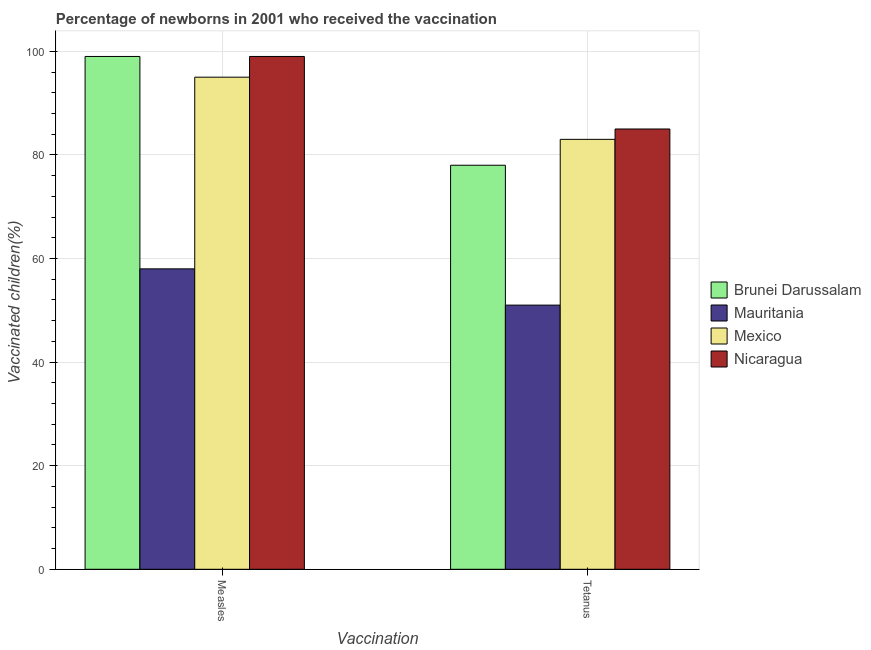How many groups of bars are there?
Your response must be concise. 2. Are the number of bars on each tick of the X-axis equal?
Provide a short and direct response. Yes. What is the label of the 1st group of bars from the left?
Offer a terse response. Measles. What is the percentage of newborns who received vaccination for measles in Nicaragua?
Offer a very short reply. 99. Across all countries, what is the maximum percentage of newborns who received vaccination for measles?
Provide a succinct answer. 99. Across all countries, what is the minimum percentage of newborns who received vaccination for measles?
Offer a very short reply. 58. In which country was the percentage of newborns who received vaccination for tetanus maximum?
Offer a terse response. Nicaragua. In which country was the percentage of newborns who received vaccination for measles minimum?
Your answer should be compact. Mauritania. What is the total percentage of newborns who received vaccination for tetanus in the graph?
Make the answer very short. 297. What is the difference between the percentage of newborns who received vaccination for measles in Mexico and that in Brunei Darussalam?
Provide a succinct answer. -4. What is the difference between the percentage of newborns who received vaccination for measles in Nicaragua and the percentage of newborns who received vaccination for tetanus in Brunei Darussalam?
Ensure brevity in your answer.  21. What is the average percentage of newborns who received vaccination for tetanus per country?
Offer a terse response. 74.25. What is the difference between the percentage of newborns who received vaccination for measles and percentage of newborns who received vaccination for tetanus in Mauritania?
Make the answer very short. 7. Is the percentage of newborns who received vaccination for tetanus in Mauritania less than that in Nicaragua?
Make the answer very short. Yes. In how many countries, is the percentage of newborns who received vaccination for tetanus greater than the average percentage of newborns who received vaccination for tetanus taken over all countries?
Make the answer very short. 3. What does the 3rd bar from the left in Tetanus represents?
Your response must be concise. Mexico. What does the 3rd bar from the right in Measles represents?
Offer a very short reply. Mauritania. How many bars are there?
Your response must be concise. 8. How many countries are there in the graph?
Your answer should be compact. 4. Are the values on the major ticks of Y-axis written in scientific E-notation?
Give a very brief answer. No. Does the graph contain any zero values?
Give a very brief answer. No. Where does the legend appear in the graph?
Give a very brief answer. Center right. How many legend labels are there?
Give a very brief answer. 4. What is the title of the graph?
Your answer should be compact. Percentage of newborns in 2001 who received the vaccination. Does "El Salvador" appear as one of the legend labels in the graph?
Your answer should be very brief. No. What is the label or title of the X-axis?
Offer a very short reply. Vaccination. What is the label or title of the Y-axis?
Your answer should be compact. Vaccinated children(%)
. What is the Vaccinated children(%)
 of Brunei Darussalam in Measles?
Offer a very short reply. 99. What is the Vaccinated children(%)
 in Mexico in Measles?
Offer a terse response. 95. Across all Vaccination, what is the maximum Vaccinated children(%)
 of Brunei Darussalam?
Your response must be concise. 99. Across all Vaccination, what is the minimum Vaccinated children(%)
 of Brunei Darussalam?
Provide a short and direct response. 78. Across all Vaccination, what is the minimum Vaccinated children(%)
 of Mauritania?
Provide a short and direct response. 51. Across all Vaccination, what is the minimum Vaccinated children(%)
 in Mexico?
Provide a short and direct response. 83. Across all Vaccination, what is the minimum Vaccinated children(%)
 of Nicaragua?
Provide a short and direct response. 85. What is the total Vaccinated children(%)
 in Brunei Darussalam in the graph?
Your answer should be very brief. 177. What is the total Vaccinated children(%)
 in Mauritania in the graph?
Ensure brevity in your answer.  109. What is the total Vaccinated children(%)
 in Mexico in the graph?
Your answer should be very brief. 178. What is the total Vaccinated children(%)
 in Nicaragua in the graph?
Give a very brief answer. 184. What is the difference between the Vaccinated children(%)
 of Nicaragua in Measles and that in Tetanus?
Provide a short and direct response. 14. What is the difference between the Vaccinated children(%)
 in Brunei Darussalam in Measles and the Vaccinated children(%)
 in Mauritania in Tetanus?
Keep it short and to the point. 48. What is the difference between the Vaccinated children(%)
 in Mauritania in Measles and the Vaccinated children(%)
 in Nicaragua in Tetanus?
Keep it short and to the point. -27. What is the difference between the Vaccinated children(%)
 of Mexico in Measles and the Vaccinated children(%)
 of Nicaragua in Tetanus?
Make the answer very short. 10. What is the average Vaccinated children(%)
 in Brunei Darussalam per Vaccination?
Your response must be concise. 88.5. What is the average Vaccinated children(%)
 of Mauritania per Vaccination?
Provide a succinct answer. 54.5. What is the average Vaccinated children(%)
 in Mexico per Vaccination?
Offer a terse response. 89. What is the average Vaccinated children(%)
 in Nicaragua per Vaccination?
Make the answer very short. 92. What is the difference between the Vaccinated children(%)
 of Brunei Darussalam and Vaccinated children(%)
 of Mexico in Measles?
Make the answer very short. 4. What is the difference between the Vaccinated children(%)
 of Brunei Darussalam and Vaccinated children(%)
 of Nicaragua in Measles?
Make the answer very short. 0. What is the difference between the Vaccinated children(%)
 of Mauritania and Vaccinated children(%)
 of Mexico in Measles?
Offer a terse response. -37. What is the difference between the Vaccinated children(%)
 in Mauritania and Vaccinated children(%)
 in Nicaragua in Measles?
Provide a short and direct response. -41. What is the difference between the Vaccinated children(%)
 in Brunei Darussalam and Vaccinated children(%)
 in Mauritania in Tetanus?
Your answer should be very brief. 27. What is the difference between the Vaccinated children(%)
 in Brunei Darussalam and Vaccinated children(%)
 in Mexico in Tetanus?
Your answer should be very brief. -5. What is the difference between the Vaccinated children(%)
 in Mauritania and Vaccinated children(%)
 in Mexico in Tetanus?
Your response must be concise. -32. What is the difference between the Vaccinated children(%)
 of Mauritania and Vaccinated children(%)
 of Nicaragua in Tetanus?
Keep it short and to the point. -34. What is the difference between the Vaccinated children(%)
 of Mexico and Vaccinated children(%)
 of Nicaragua in Tetanus?
Ensure brevity in your answer.  -2. What is the ratio of the Vaccinated children(%)
 of Brunei Darussalam in Measles to that in Tetanus?
Provide a short and direct response. 1.27. What is the ratio of the Vaccinated children(%)
 in Mauritania in Measles to that in Tetanus?
Offer a terse response. 1.14. What is the ratio of the Vaccinated children(%)
 of Mexico in Measles to that in Tetanus?
Offer a terse response. 1.14. What is the ratio of the Vaccinated children(%)
 of Nicaragua in Measles to that in Tetanus?
Offer a terse response. 1.16. What is the difference between the highest and the second highest Vaccinated children(%)
 of Brunei Darussalam?
Provide a short and direct response. 21. What is the difference between the highest and the second highest Vaccinated children(%)
 of Mauritania?
Your answer should be very brief. 7. What is the difference between the highest and the second highest Vaccinated children(%)
 of Mexico?
Your answer should be compact. 12. What is the difference between the highest and the lowest Vaccinated children(%)
 in Mauritania?
Keep it short and to the point. 7. What is the difference between the highest and the lowest Vaccinated children(%)
 of Mexico?
Keep it short and to the point. 12. 